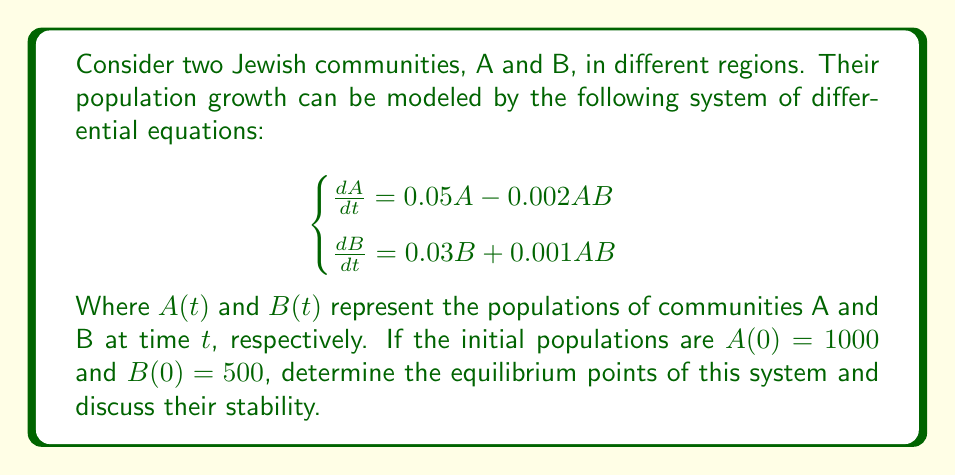Provide a solution to this math problem. To solve this problem, we'll follow these steps:

1) Find the equilibrium points by setting $\frac{dA}{dt} = 0$ and $\frac{dB}{dt} = 0$:

   $$0.05A - 0.002AB = 0$$
   $$0.03B + 0.001AB = 0$$

2) From the first equation:
   $$A(0.05 - 0.002B) = 0$$
   This gives us $A = 0$ or $B = 25$

3) From the second equation:
   $$B(0.03 + 0.001A) = 0$$
   This gives us $B = 0$ or $A = -30$

4) Combining these results, we get three equilibrium points:
   $(0, 0)$, $(25, 0)$, and $(0, -30)$

   However, since population can't be negative, we discard $(0, -30)$.

5) To determine stability, we need to find the Jacobian matrix:

   $$J = \begin{bmatrix}
   0.05 - 0.002B & -0.002A \\
   0.001B & 0.03 + 0.001A
   \end{bmatrix}$$

6) Evaluate J at $(0, 0)$:
   
   $$J_{(0,0)} = \begin{bmatrix}
   0.05 & 0 \\
   0 & 0.03
   \end{bmatrix}$$

   Both eigenvalues are positive, so $(0, 0)$ is an unstable node.

7) Evaluate J at $(25, 0)$:

   $$J_{(25,0)} = \begin{bmatrix}
   0 & -0.05 \\
   0 & 0.0525
   \end{bmatrix}$$

   One eigenvalue is 0 and the other is positive, so $(25, 0)$ is unstable.

Therefore, the system has no stable equilibrium points within the first quadrant (where both populations are non-negative).
Answer: Equilibrium points: $(0, 0)$ and $(25, 0)$. Both are unstable. 